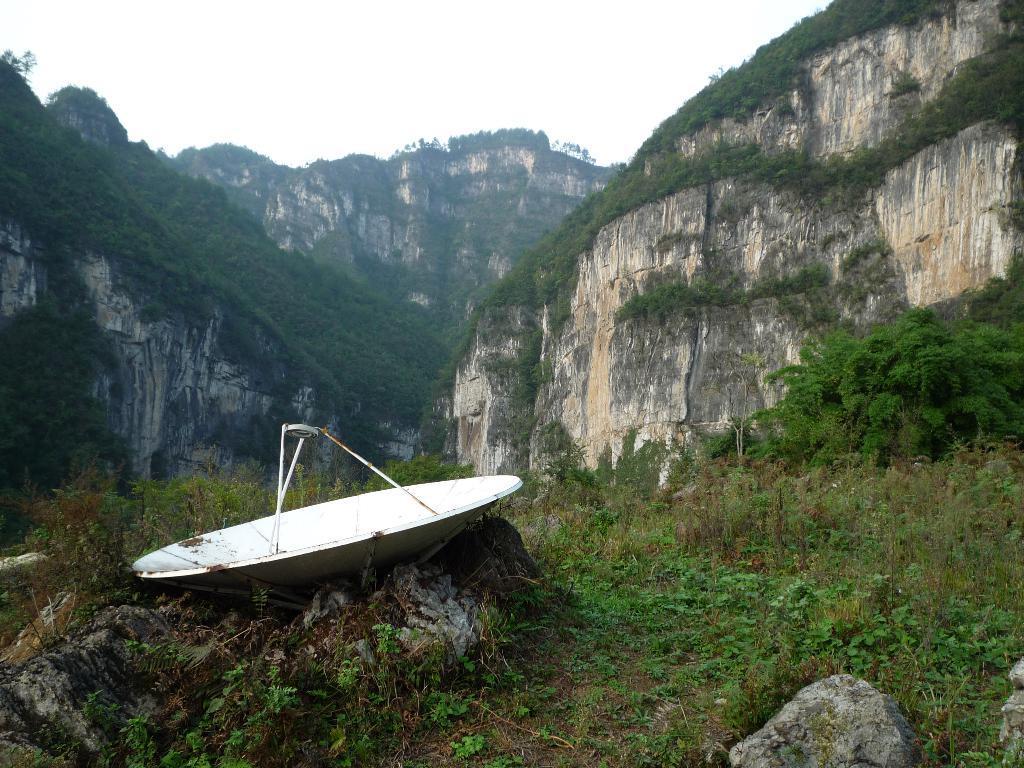How would you summarize this image in a sentence or two? On the left side, there is a white color antenna on a rock. Beside this rock, there's grass on the ground. On the right side, there is a stone on the ground. Beside this stone, there's grass on the ground. In the background, there are mountains and there is sky. 